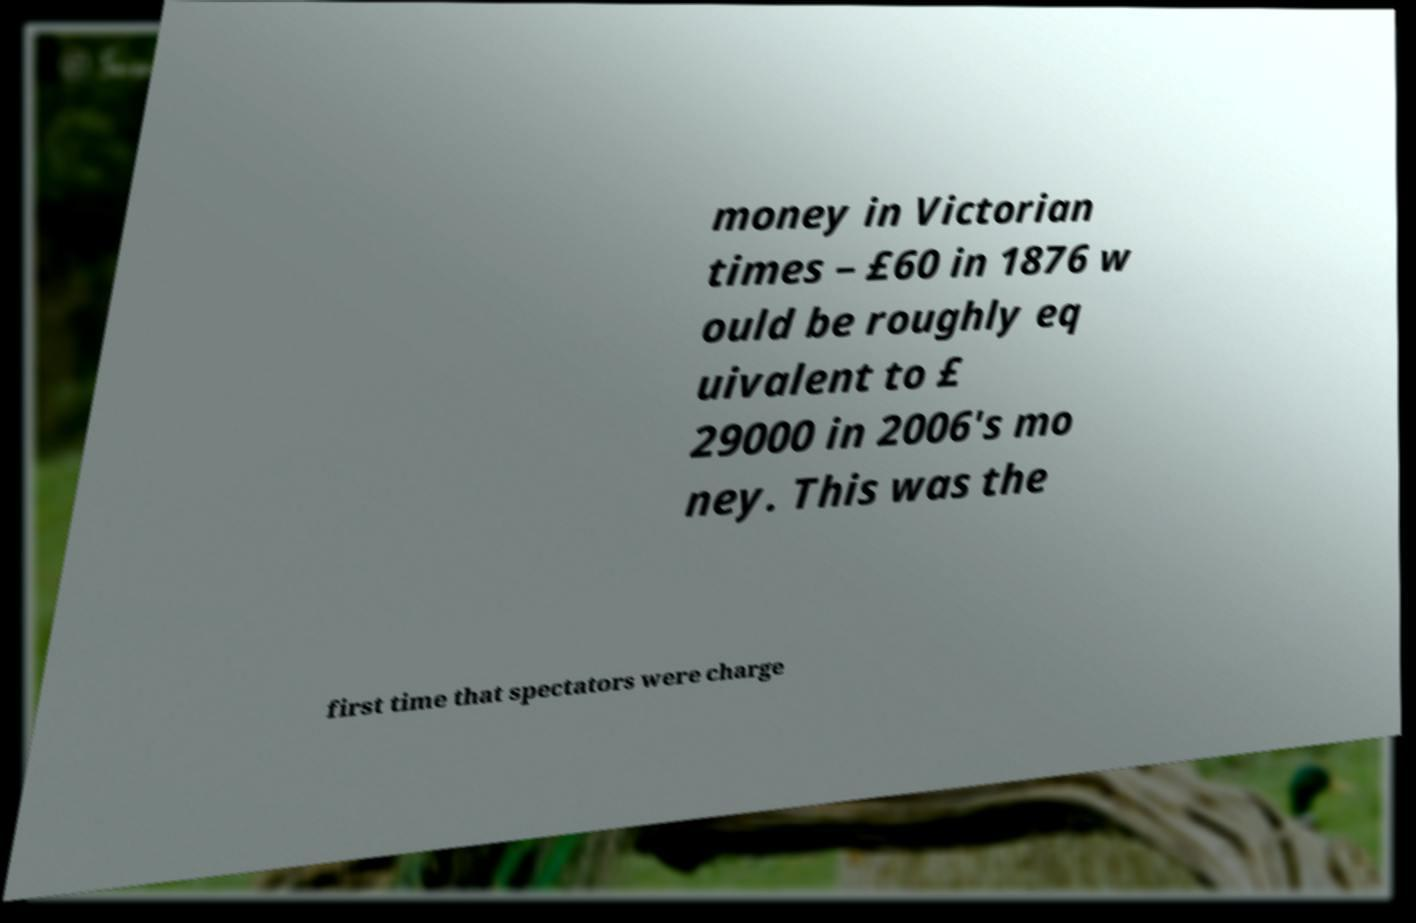For documentation purposes, I need the text within this image transcribed. Could you provide that? money in Victorian times – £60 in 1876 w ould be roughly eq uivalent to £ 29000 in 2006's mo ney. This was the first time that spectators were charge 